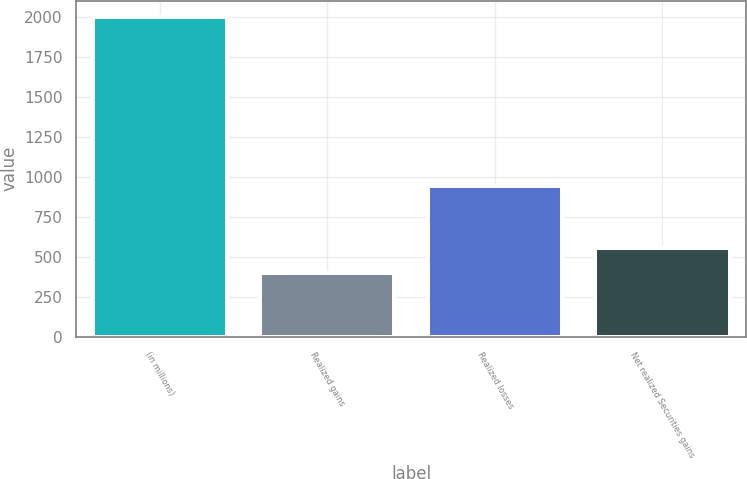Convert chart to OTSL. <chart><loc_0><loc_0><loc_500><loc_500><bar_chart><fcel>(in millions)<fcel>Realized gains<fcel>Realized losses<fcel>Net realized Securities gains<nl><fcel>2006<fcel>399<fcel>942<fcel>559.7<nl></chart> 